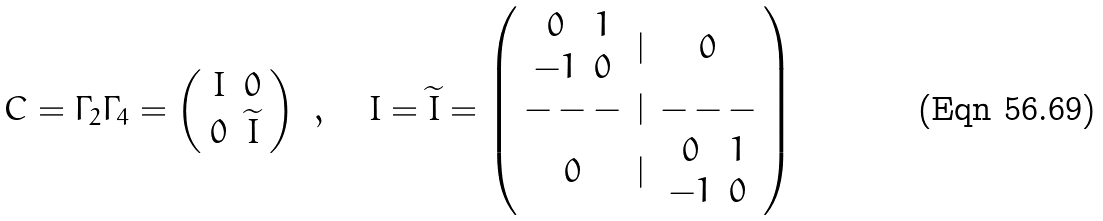<formula> <loc_0><loc_0><loc_500><loc_500>C = \Gamma _ { 2 } \Gamma _ { 4 } = \left ( \begin{array} { c c } I & 0 \\ 0 & \widetilde { I } \end{array} \right ) \ , \quad I = \widetilde { I } = \left ( \begin{array} { c c c } \begin{array} { c c } 0 & 1 \\ - 1 & 0 \end{array} & | & 0 \\ - - - & | & - - - \\ 0 & | & \begin{array} { c c } 0 & 1 \\ - 1 & 0 \end{array} \end{array} \right )</formula> 